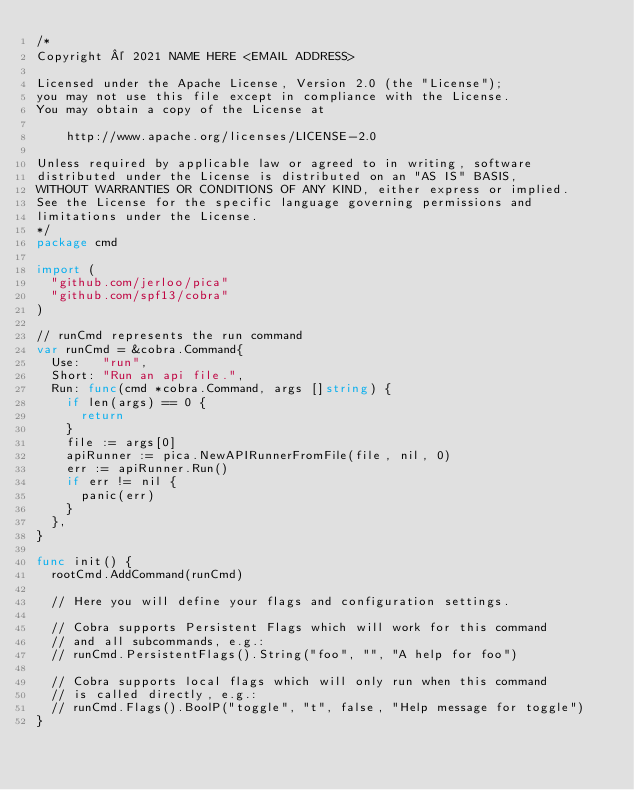<code> <loc_0><loc_0><loc_500><loc_500><_Go_>/*
Copyright © 2021 NAME HERE <EMAIL ADDRESS>

Licensed under the Apache License, Version 2.0 (the "License");
you may not use this file except in compliance with the License.
You may obtain a copy of the License at

    http://www.apache.org/licenses/LICENSE-2.0

Unless required by applicable law or agreed to in writing, software
distributed under the License is distributed on an "AS IS" BASIS,
WITHOUT WARRANTIES OR CONDITIONS OF ANY KIND, either express or implied.
See the License for the specific language governing permissions and
limitations under the License.
*/
package cmd

import (
	"github.com/jerloo/pica"
	"github.com/spf13/cobra"
)

// runCmd represents the run command
var runCmd = &cobra.Command{
	Use:   "run",
	Short: "Run an api file.",
	Run: func(cmd *cobra.Command, args []string) {
		if len(args) == 0 {
			return
		}
		file := args[0]
		apiRunner := pica.NewAPIRunnerFromFile(file, nil, 0)
		err := apiRunner.Run()
		if err != nil {
			panic(err)
		}
	},
}

func init() {
	rootCmd.AddCommand(runCmd)

	// Here you will define your flags and configuration settings.

	// Cobra supports Persistent Flags which will work for this command
	// and all subcommands, e.g.:
	// runCmd.PersistentFlags().String("foo", "", "A help for foo")

	// Cobra supports local flags which will only run when this command
	// is called directly, e.g.:
	// runCmd.Flags().BoolP("toggle", "t", false, "Help message for toggle")
}
</code> 